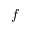<formula> <loc_0><loc_0><loc_500><loc_500>f</formula> 